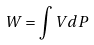Convert formula to latex. <formula><loc_0><loc_0><loc_500><loc_500>W = \int V d P</formula> 